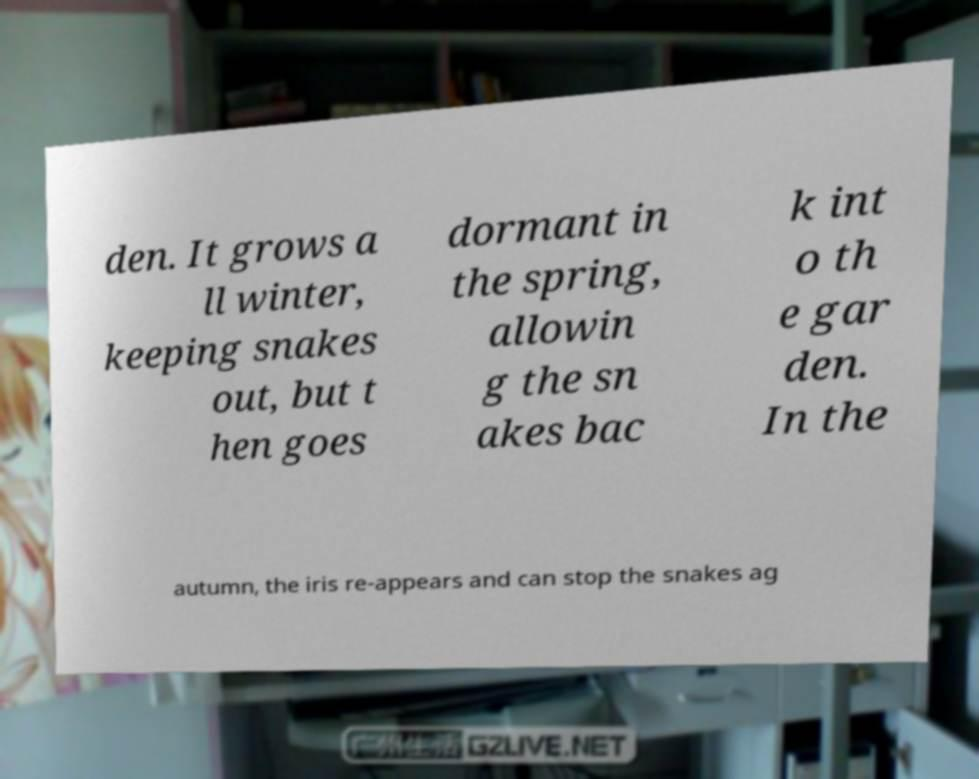For documentation purposes, I need the text within this image transcribed. Could you provide that? den. It grows a ll winter, keeping snakes out, but t hen goes dormant in the spring, allowin g the sn akes bac k int o th e gar den. In the autumn, the iris re-appears and can stop the snakes ag 